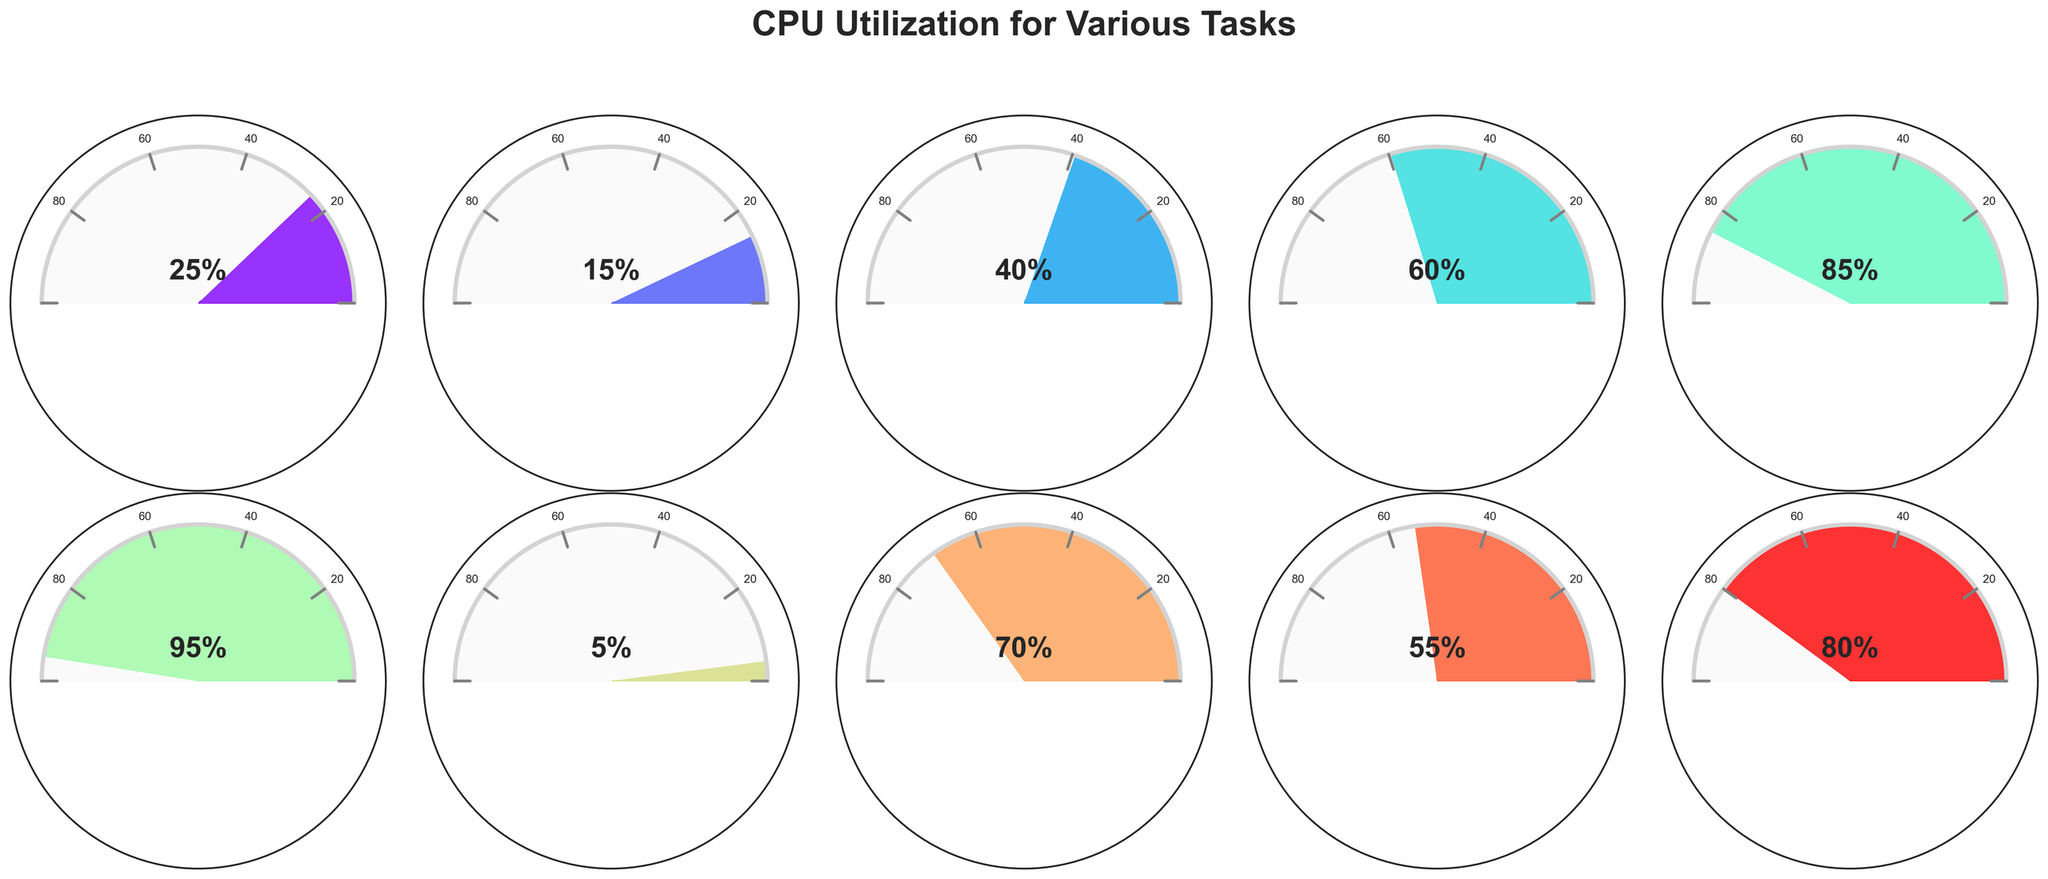What is the CPU utilization during Gaming (Minecraft)? To find the CPU utilization during Gaming (Minecraft), look for the gauge chart labeled "Gaming (Minecraft)" and read the CPU utilization percentage displayed inside the gauge.
Answer: 60% Which task shows the highest CPU utilization? Compare the CPU utilization percentages shown on all the gauge charts. The highest value is the one shown inside the "3D Rendering" gauge chart.
Answer: 3D Rendering What is the median CPU utilization among all the tasks? First, list all the CPU utilizations: 25, 15, 40, 60, 85, 95, 5, 70, 55, 80. Then, sort them: 5, 15, 25, 40, 55, 60, 70, 80, 85, 95. Since there are 10 values, the median is the average of the 5th and 6th values: (55 + 60) / 2.
Answer: 57.5% Which task has a lower CPU utilization, Video Playback or Compiling Code? Look at the CPU utilization values for both "Video Playback" and "Compiling Code". "Video Playback" shows 40% while "Compiling Code" shows 85%.
Answer: Video Playback What's the difference in CPU utilization between Web Browsing and Virus Scan? To find the difference, subtract the CPU utilization of Web Browsing from that of Virus Scan: 55% - 25%.
Answer: 30% Which tasks have a CPU utilization of 70% or more? Identify the tasks whose gauge charts show a CPU utilization percentage of 70% or higher. These tasks are "Compiling Code," "3D Rendering," "Windows Update," and "Video Encoding".
Answer: Compiling Code, 3D Rendering, Windows Update, Video Encoding How many tasks have a CPU utilization below 30%? List the CPU utilization values: 25, 15, 40, 60, 85, 95, 5, 70, 55, 80. Count the number of values below 30, which are: 25, 15, 5.
Answer: 3 What's the average CPU utilization for all the tasks? First, sum all the CPU utilization values: 25 + 15 + 40 + 60 + 85 + 95 + 5 + 70 + 55 + 80 = 530. Then, divide by the number of tasks (10): 530 / 10.
Answer: 53% Which task uses more CPU, Windows Update or Virus Scan? Compare the CPU utilization values for "Windows Update" and "Virus Scan". "Windows Update" shows 70% while "Virus Scan" shows 55%.
Answer: Windows Update 